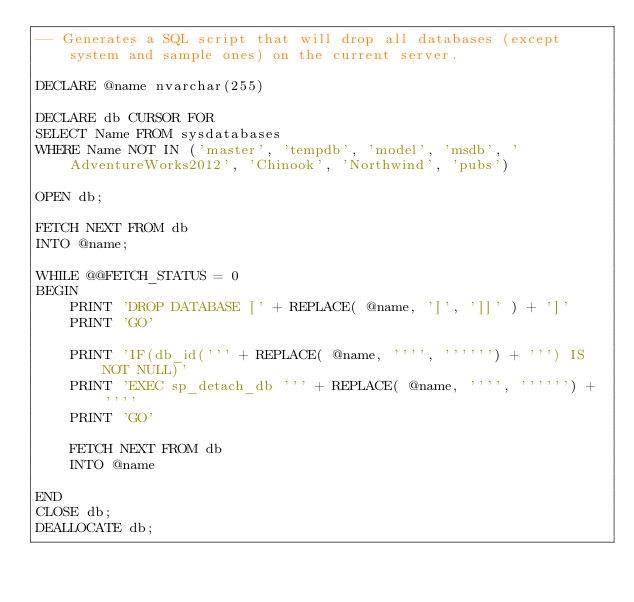Convert code to text. <code><loc_0><loc_0><loc_500><loc_500><_SQL_>-- Generates a SQL script that will drop all databases (except system and sample ones) on the current server.

DECLARE @name nvarchar(255)

DECLARE db CURSOR FOR 
SELECT Name FROM sysdatabases
WHERE Name NOT IN ('master', 'tempdb', 'model', 'msdb', 'AdventureWorks2012', 'Chinook', 'Northwind', 'pubs')

OPEN db;

FETCH NEXT FROM db 
INTO @name;

WHILE @@FETCH_STATUS = 0
BEGIN
    PRINT 'DROP DATABASE [' + REPLACE( @name, ']', ']]' ) + ']'
    PRINT 'GO'

    PRINT 'IF(db_id(''' + REPLACE( @name, '''', '''''') + ''') IS NOT NULL)'
    PRINT 'EXEC sp_detach_db ''' + REPLACE( @name, '''', '''''') + ''''
    PRINT 'GO'
    
    FETCH NEXT FROM db 
    INTO @name

END
CLOSE db;
DEALLOCATE db;</code> 